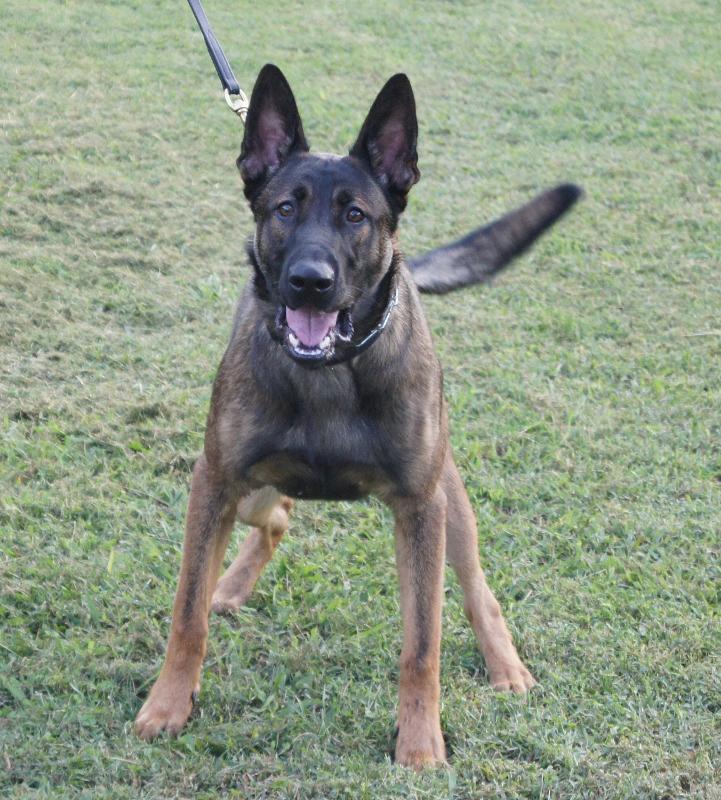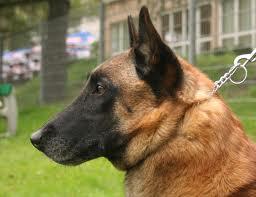The first image is the image on the left, the second image is the image on the right. Examine the images to the left and right. Is the description "At least one image has no grass." accurate? Answer yes or no. No. 